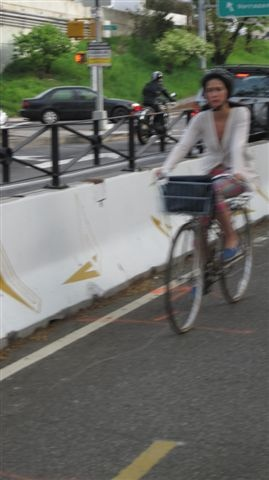Describe the objects in this image and their specific colors. I can see people in beige, darkgray, gray, maroon, and black tones, bicycle in beige, gray, black, and darkgray tones, car in beige, black, gray, and purple tones, car in beige, black, gray, and blue tones, and handbag in beige, black, and gray tones in this image. 